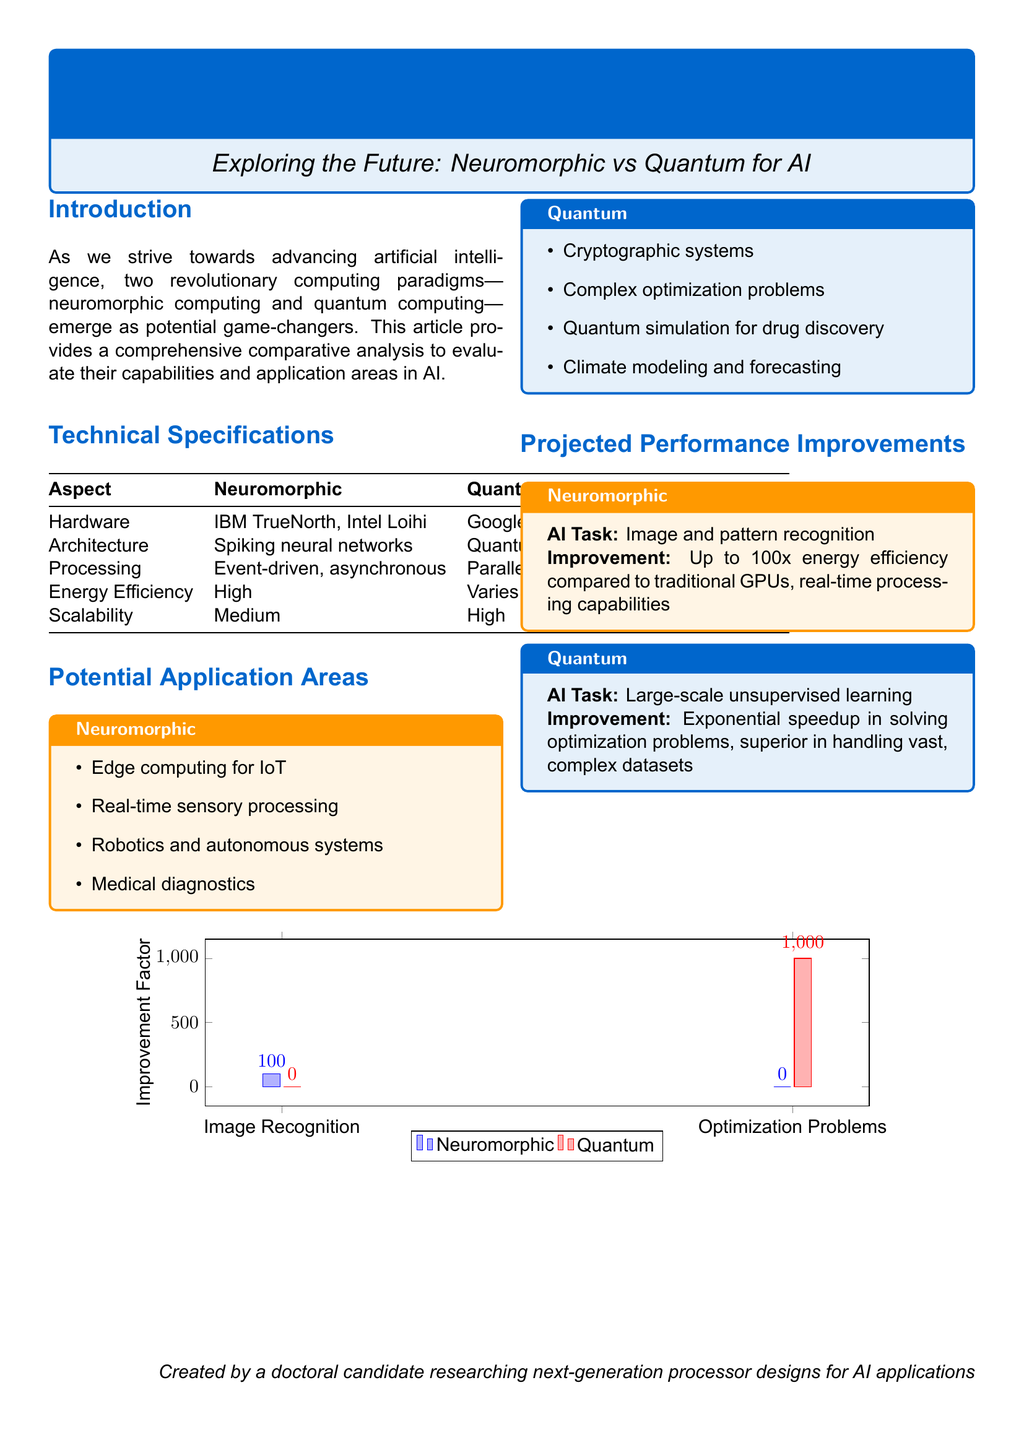What is a primary application area for neuromorphic computing? This information can be found in the section detailing potential application areas for neuromorphic computing.
Answer: Edge computing for IoT Which hardware is associated with quantum computing? This information is included in the technical specifications section under hardware for quantum computing.
Answer: Google Sycamore, IBM Q System One What is the improvement factor for image recognition in neuromorphic computing? The improvement factor for image recognition is noted in the section on projected performance improvements under neuromorphic computing.
Answer: Up to 100x What type of architecture does neuromorphic computing use? This detail is found in the technical specifications section under architecture for neuromorphic computing.
Answer: Spiking neural networks What is the expected improvement in solving optimization problems for quantum computing? This information is outlined in the section on projected performance improvements under quantum computing.
Answer: Exponential speedup Which computing paradigm is expected to have medium scalability? This detail can be found in the technical specifications section regarding scalability.
Answer: Neuromorphic What task does quantum computing excel in, according to the document? This question refers to the applications listed for quantum computing in the potential application areas section.
Answer: Large-scale unsupervised learning What are the two primary computing paradigms compared in this document? This information can be deduced from the title and introduction of the document.
Answer: Neuromorphic and Quantum What does the energy efficiency of quantum computing vary? This information is provided in the technical specifications section under energy efficiency.
Answer: Varies 